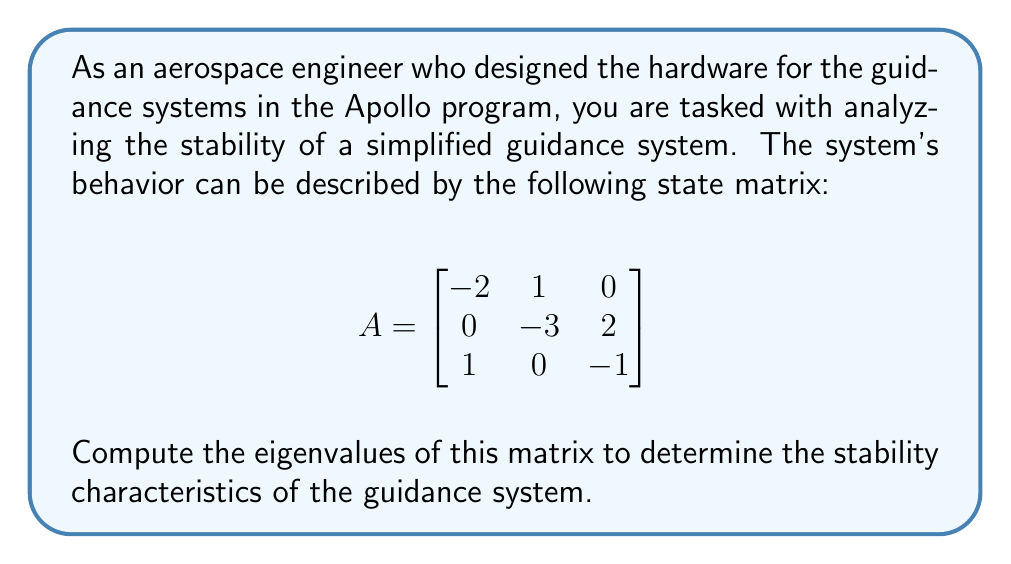Teach me how to tackle this problem. To find the eigenvalues of matrix A, we need to solve the characteristic equation:

1) First, we form the characteristic equation:
   $$det(A - \lambda I) = 0$$
   where $\lambda$ represents the eigenvalues and I is the 3x3 identity matrix.

2) Expanding this, we get:
   $$\begin{vmatrix}
   -2-\lambda & 1 & 0 \\
   0 & -3-\lambda & 2 \\
   1 & 0 & -1-\lambda
   \end{vmatrix} = 0$$

3) Calculate the determinant:
   $$(-2-\lambda)[(-3-\lambda)(-1-\lambda) - 0] - 1[0 - 2] = 0$$

4) Simplify:
   $$(-2-\lambda)[(\lambda^2 + 4\lambda + 3)] + 2 = 0$$

5) Expand:
   $$-\lambda^3 - 4\lambda^2 - 3\lambda + 2 = 0$$

6) Rearrange to standard form:
   $$\lambda^3 + 4\lambda^2 + 3\lambda - 2 = 0$$

7) This cubic equation can be solved using various methods. One eigenvalue can be found by inspection: $\lambda = -2$ satisfies the equation.

8) Using polynomial long division or the rational root theorem, we can factor out $(\lambda + 2)$:
   $$(\lambda + 2)(\lambda^2 + 2\lambda + 1) = 0$$

9) The quadratic factor can be solved using the quadratic formula:
   $$\lambda = \frac{-2 \pm \sqrt{4 - 4}}{2} = -1$$

Therefore, the eigenvalues are $\lambda_1 = -2$, $\lambda_2 = -1$, and $\lambda_3 = -1$.
Answer: $\lambda_1 = -2$, $\lambda_2 = \lambda_3 = -1$ 